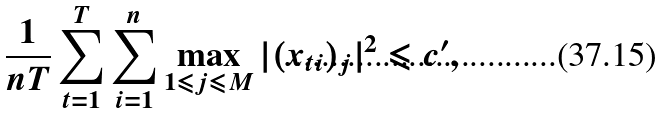<formula> <loc_0><loc_0><loc_500><loc_500>\frac { 1 } { n T } \sum _ { t = 1 } ^ { T } \sum _ { i = 1 } ^ { n } \max _ { 1 \leqslant j \leqslant M } | ( x _ { t i } ) _ { j } | ^ { 2 } \leqslant c ^ { \prime } ,</formula> 